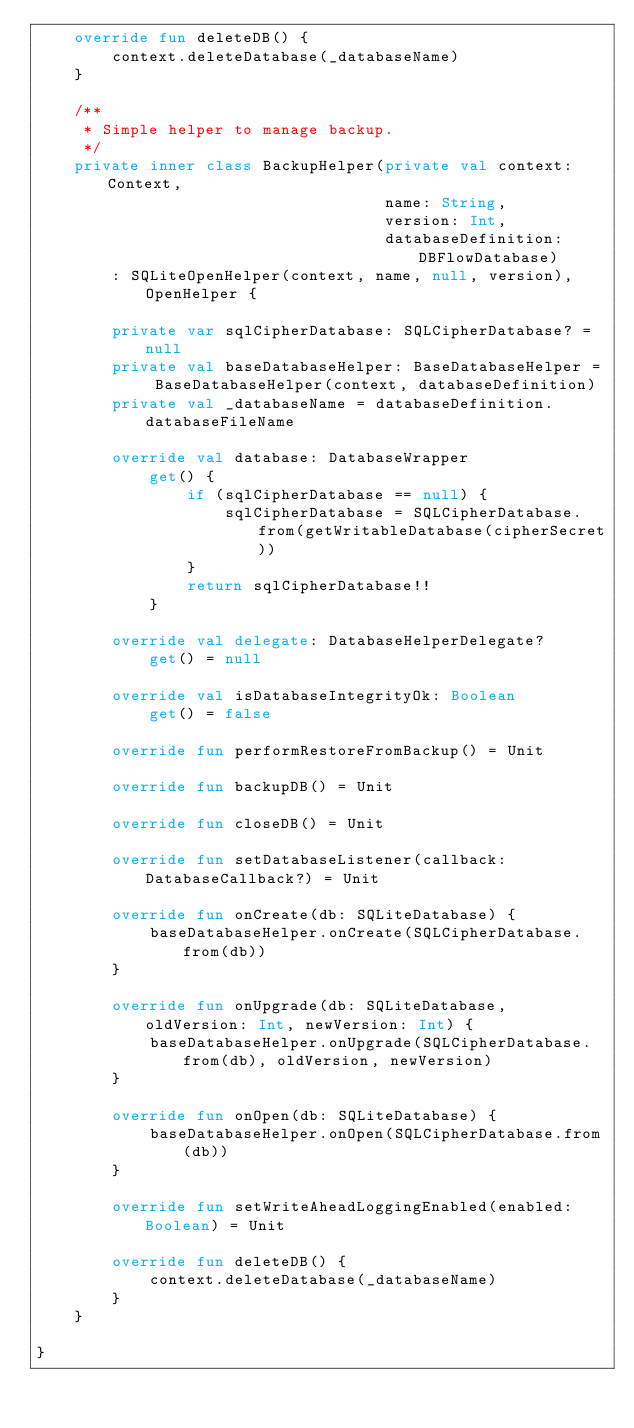Convert code to text. <code><loc_0><loc_0><loc_500><loc_500><_Kotlin_>    override fun deleteDB() {
        context.deleteDatabase(_databaseName)
    }

    /**
     * Simple helper to manage backup.
     */
    private inner class BackupHelper(private val context: Context,
                                     name: String,
                                     version: Int,
                                     databaseDefinition: DBFlowDatabase)
        : SQLiteOpenHelper(context, name, null, version), OpenHelper {

        private var sqlCipherDatabase: SQLCipherDatabase? = null
        private val baseDatabaseHelper: BaseDatabaseHelper = BaseDatabaseHelper(context, databaseDefinition)
        private val _databaseName = databaseDefinition.databaseFileName

        override val database: DatabaseWrapper
            get() {
                if (sqlCipherDatabase == null) {
                    sqlCipherDatabase = SQLCipherDatabase.from(getWritableDatabase(cipherSecret))
                }
                return sqlCipherDatabase!!
            }

        override val delegate: DatabaseHelperDelegate?
            get() = null

        override val isDatabaseIntegrityOk: Boolean
            get() = false

        override fun performRestoreFromBackup() = Unit

        override fun backupDB() = Unit

        override fun closeDB() = Unit

        override fun setDatabaseListener(callback: DatabaseCallback?) = Unit

        override fun onCreate(db: SQLiteDatabase) {
            baseDatabaseHelper.onCreate(SQLCipherDatabase.from(db))
        }

        override fun onUpgrade(db: SQLiteDatabase, oldVersion: Int, newVersion: Int) {
            baseDatabaseHelper.onUpgrade(SQLCipherDatabase.from(db), oldVersion, newVersion)
        }

        override fun onOpen(db: SQLiteDatabase) {
            baseDatabaseHelper.onOpen(SQLCipherDatabase.from(db))
        }

        override fun setWriteAheadLoggingEnabled(enabled: Boolean) = Unit

        override fun deleteDB() {
            context.deleteDatabase(_databaseName)
        }
    }

}
</code> 